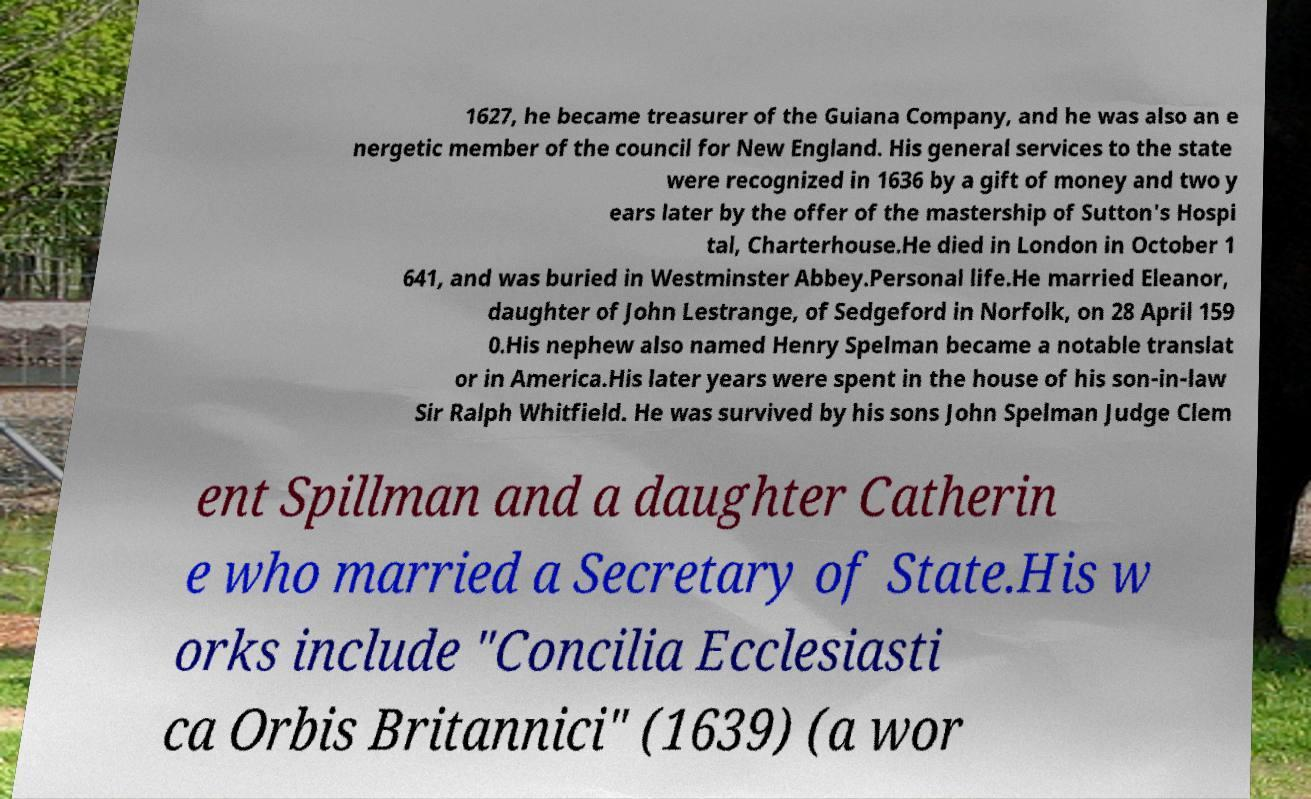Could you extract and type out the text from this image? 1627, he became treasurer of the Guiana Company, and he was also an e nergetic member of the council for New England. His general services to the state were recognized in 1636 by a gift of money and two y ears later by the offer of the mastership of Sutton's Hospi tal, Charterhouse.He died in London in October 1 641, and was buried in Westminster Abbey.Personal life.He married Eleanor, daughter of John Lestrange, of Sedgeford in Norfolk, on 28 April 159 0.His nephew also named Henry Spelman became a notable translat or in America.His later years were spent in the house of his son-in-law Sir Ralph Whitfield. He was survived by his sons John Spelman Judge Clem ent Spillman and a daughter Catherin e who married a Secretary of State.His w orks include "Concilia Ecclesiasti ca Orbis Britannici" (1639) (a wor 